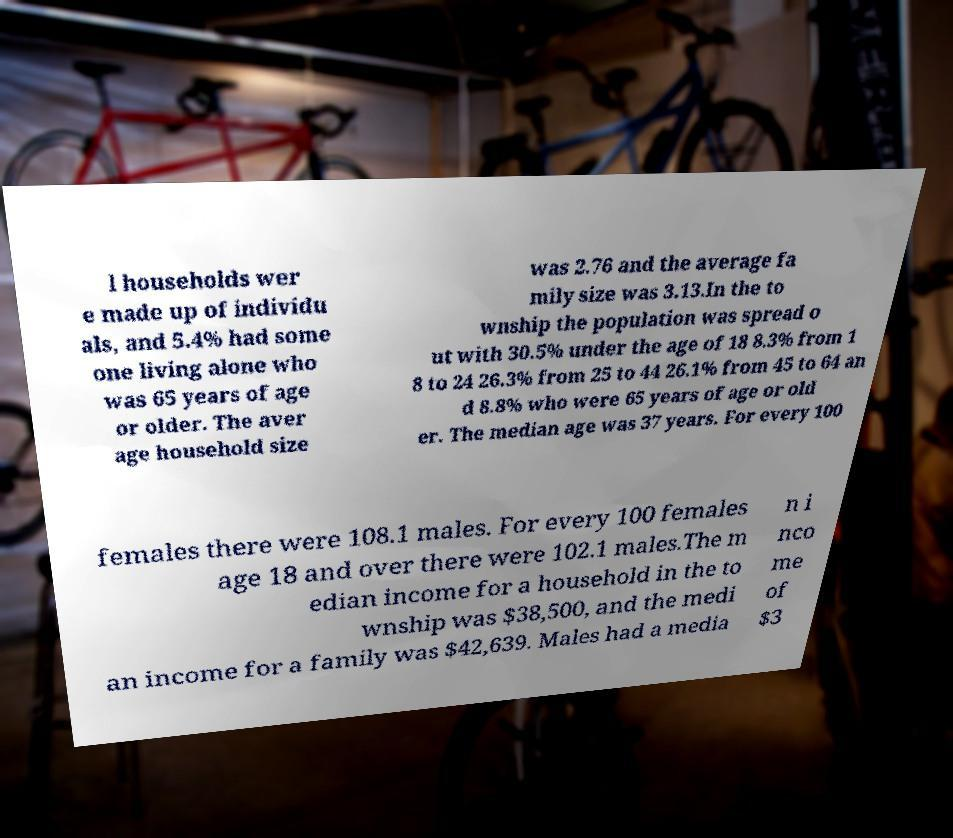Could you extract and type out the text from this image? l households wer e made up of individu als, and 5.4% had some one living alone who was 65 years of age or older. The aver age household size was 2.76 and the average fa mily size was 3.13.In the to wnship the population was spread o ut with 30.5% under the age of 18 8.3% from 1 8 to 24 26.3% from 25 to 44 26.1% from 45 to 64 an d 8.8% who were 65 years of age or old er. The median age was 37 years. For every 100 females there were 108.1 males. For every 100 females age 18 and over there were 102.1 males.The m edian income for a household in the to wnship was $38,500, and the medi an income for a family was $42,639. Males had a media n i nco me of $3 